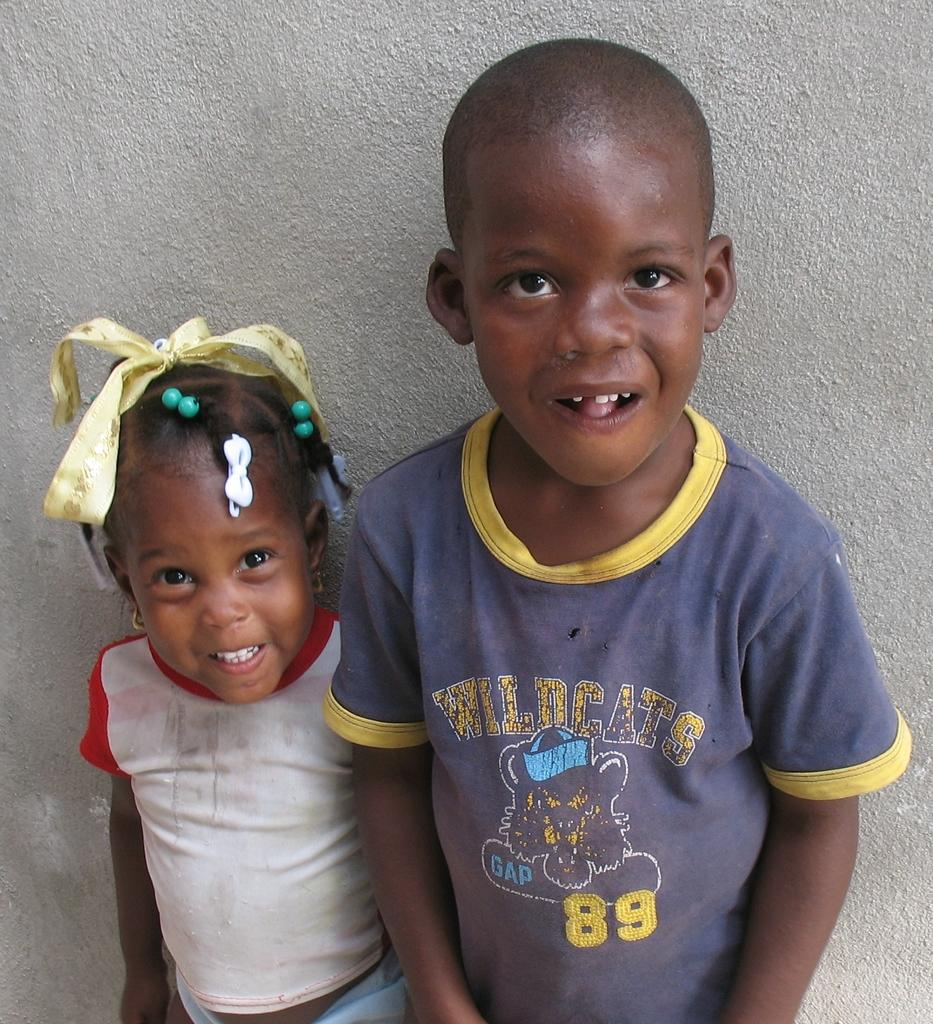How many kids are in the image? There are two kids standing in the center of the image. What can be seen in the background of the image? There is a wall in the background of the image. What is the guide's name in the image? There is no guide present in the image; it features two kids standing in the center. 